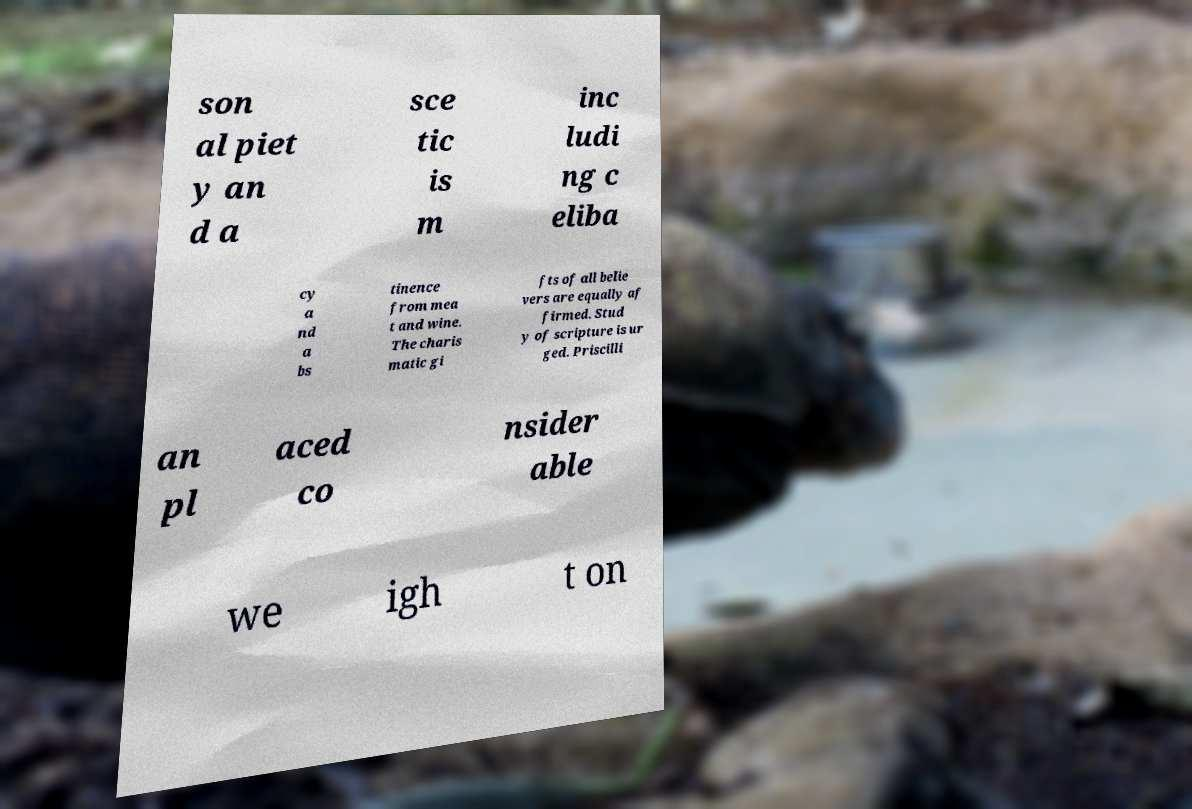Can you accurately transcribe the text from the provided image for me? son al piet y an d a sce tic is m inc ludi ng c eliba cy a nd a bs tinence from mea t and wine. The charis matic gi fts of all belie vers are equally af firmed. Stud y of scripture is ur ged. Priscilli an pl aced co nsider able we igh t on 